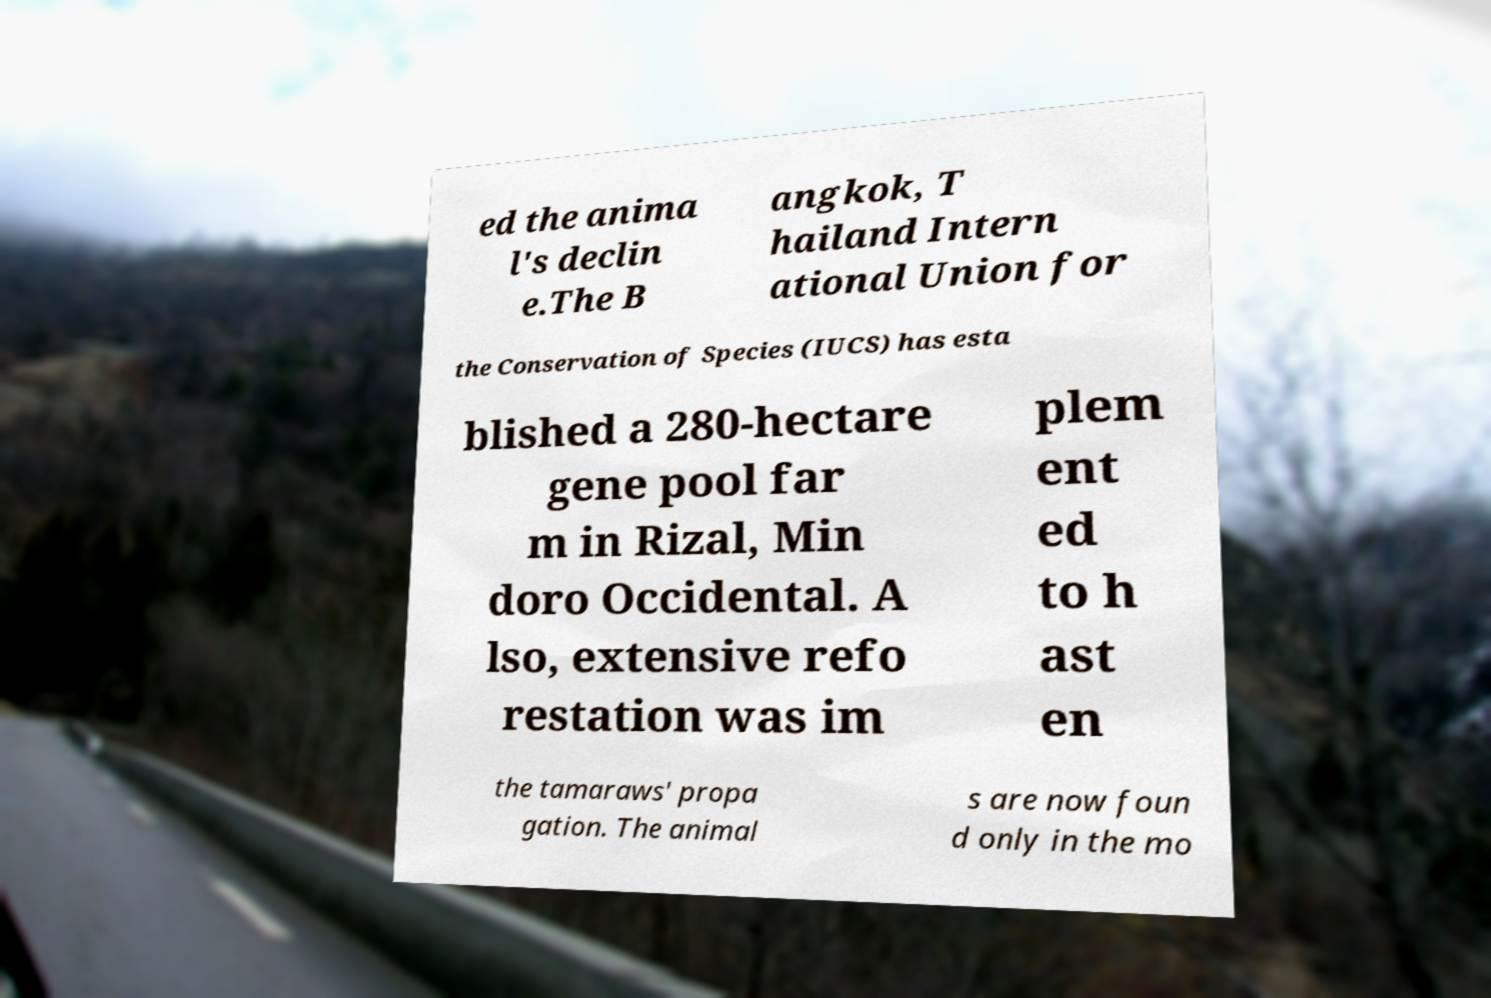Can you read and provide the text displayed in the image?This photo seems to have some interesting text. Can you extract and type it out for me? ed the anima l's declin e.The B angkok, T hailand Intern ational Union for the Conservation of Species (IUCS) has esta blished a 280-hectare gene pool far m in Rizal, Min doro Occidental. A lso, extensive refo restation was im plem ent ed to h ast en the tamaraws' propa gation. The animal s are now foun d only in the mo 